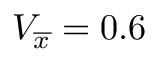<formula> <loc_0><loc_0><loc_500><loc_500>V _ { \overline { x } } = 0 . 6</formula> 